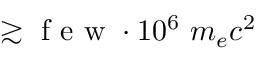<formula> <loc_0><loc_0><loc_500><loc_500>\gtrsim f e w \cdot 1 0 ^ { 6 } m _ { e } c ^ { 2 }</formula> 